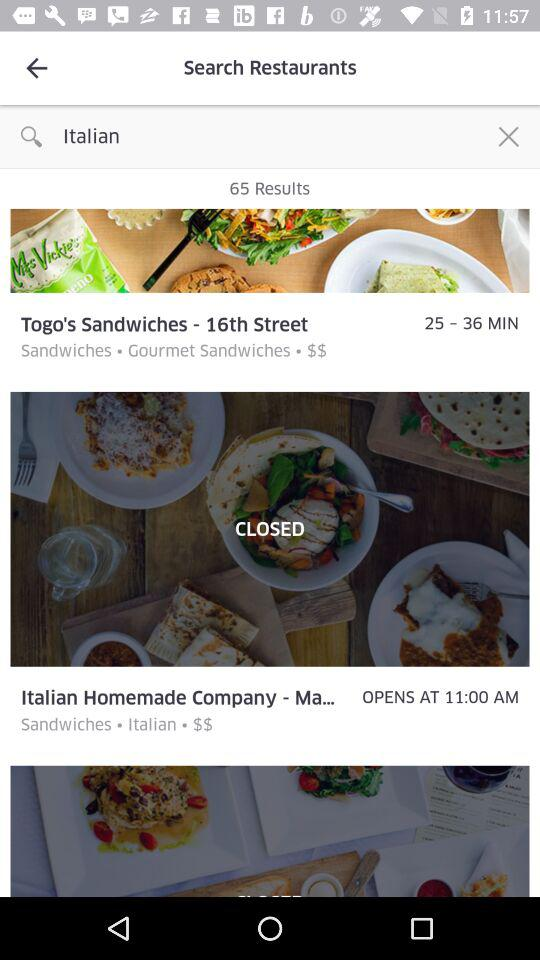How many results are there? There are 65 results. 